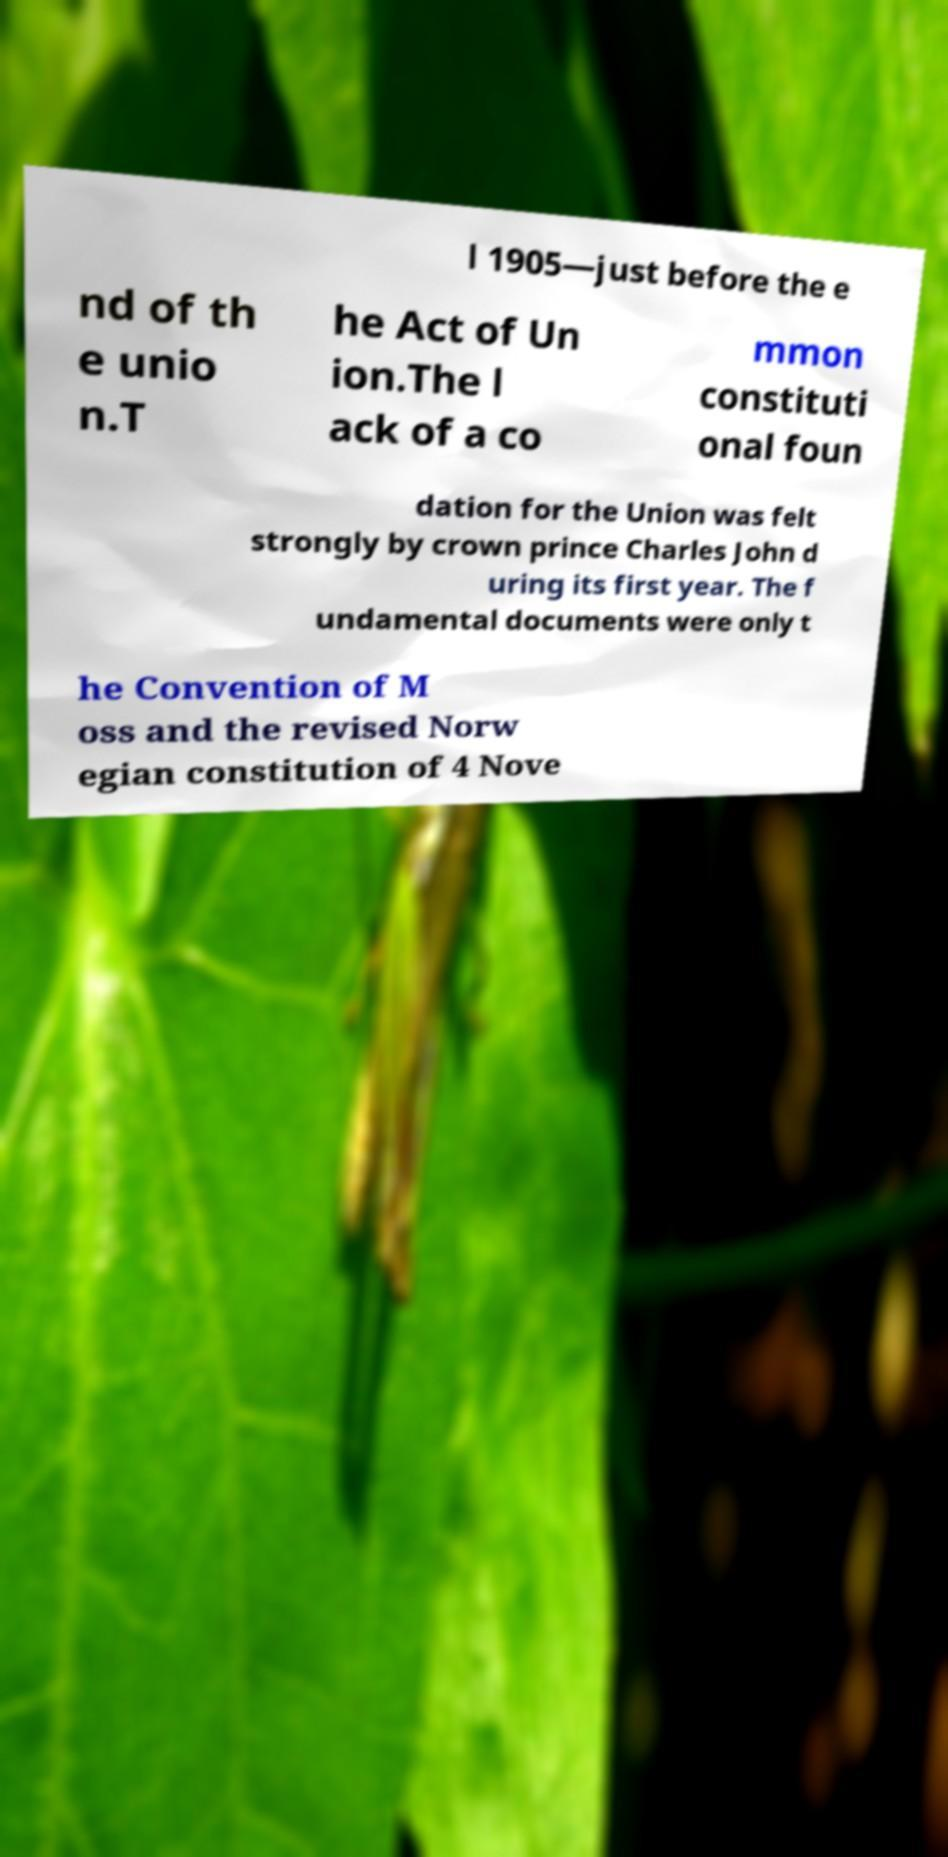Please read and relay the text visible in this image. What does it say? l 1905—just before the e nd of th e unio n.T he Act of Un ion.The l ack of a co mmon constituti onal foun dation for the Union was felt strongly by crown prince Charles John d uring its first year. The f undamental documents were only t he Convention of M oss and the revised Norw egian constitution of 4 Nove 